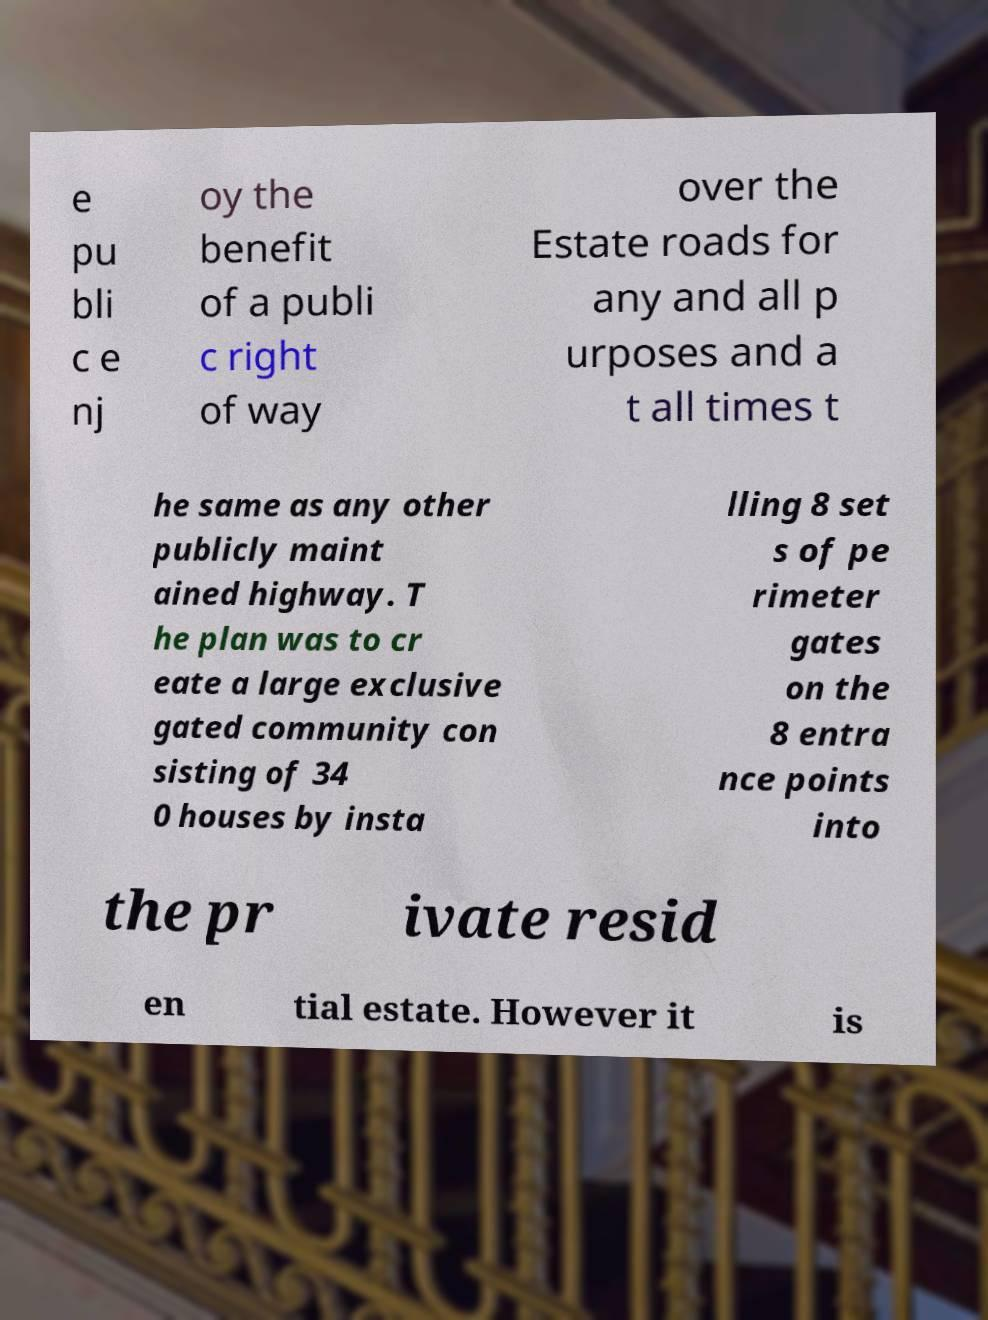Can you read and provide the text displayed in the image?This photo seems to have some interesting text. Can you extract and type it out for me? e pu bli c e nj oy the benefit of a publi c right of way over the Estate roads for any and all p urposes and a t all times t he same as any other publicly maint ained highway. T he plan was to cr eate a large exclusive gated community con sisting of 34 0 houses by insta lling 8 set s of pe rimeter gates on the 8 entra nce points into the pr ivate resid en tial estate. However it is 